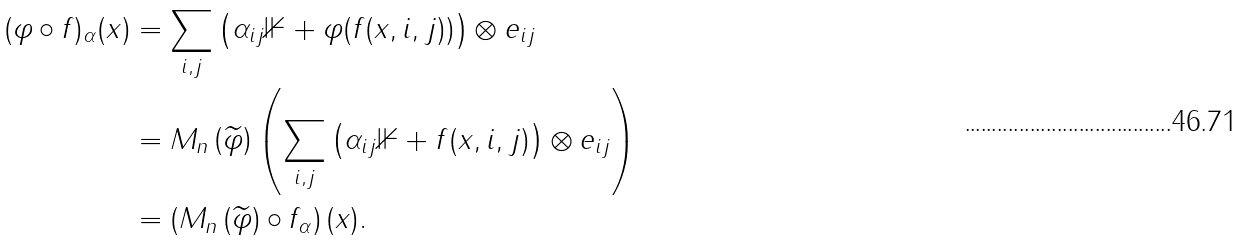<formula> <loc_0><loc_0><loc_500><loc_500>( \varphi \circ f ) _ { \alpha } ( x ) & = \sum _ { i , j } \left ( \alpha _ { i j } \mathbb { 1 } + \varphi ( f ( x , i , j ) ) \right ) \otimes e _ { i j } \\ & = M _ { n } \left ( \widetilde { \varphi } \right ) \left ( \sum _ { i , j } \left ( \alpha _ { i j } \mathbb { 1 } + f ( x , i , j ) \right ) \otimes e _ { i j } \right ) \\ & = \left ( M _ { n } \left ( \widetilde { \varphi } \right ) \circ f _ { \alpha } \right ) ( x ) .</formula> 